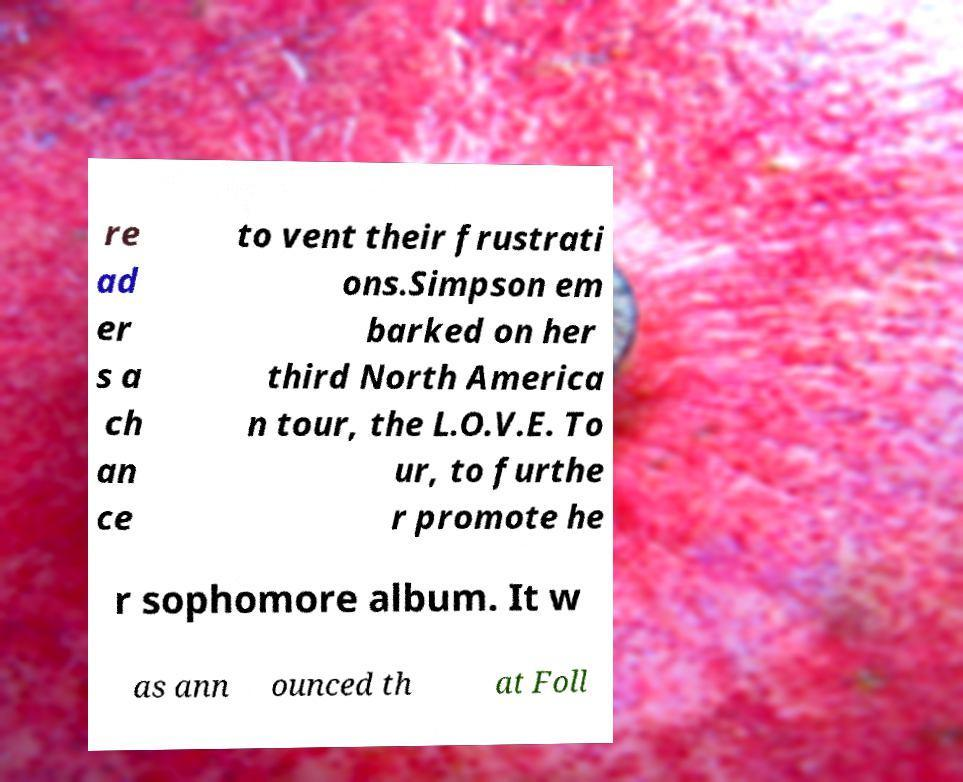Please read and relay the text visible in this image. What does it say? re ad er s a ch an ce to vent their frustrati ons.Simpson em barked on her third North America n tour, the L.O.V.E. To ur, to furthe r promote he r sophomore album. It w as ann ounced th at Foll 